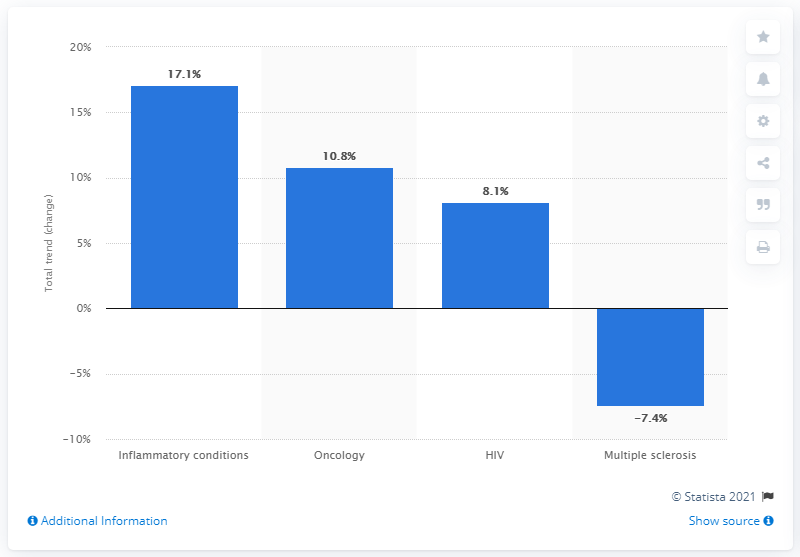Give some essential details in this illustration. Inflammatory conditions had an increasing total trend of 17.1% in 2019. 